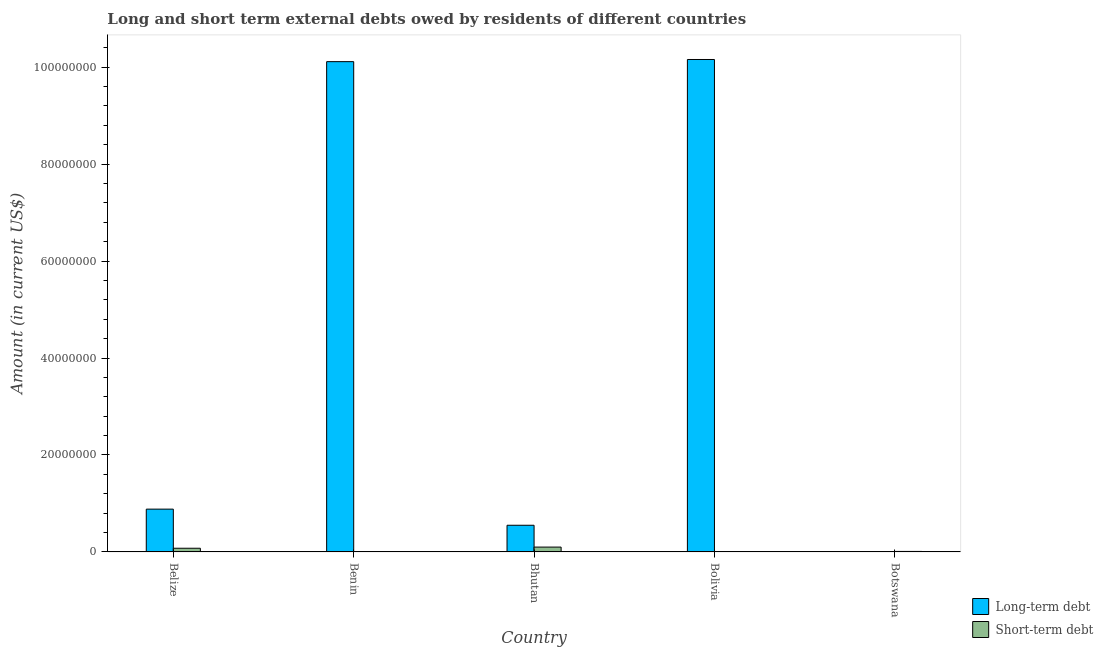What is the label of the 2nd group of bars from the left?
Your response must be concise. Benin. In how many cases, is the number of bars for a given country not equal to the number of legend labels?
Your answer should be very brief. 3. What is the short-term debts owed by residents in Belize?
Ensure brevity in your answer.  7.56e+05. Across all countries, what is the maximum long-term debts owed by residents?
Provide a short and direct response. 1.02e+08. What is the total short-term debts owed by residents in the graph?
Ensure brevity in your answer.  1.85e+06. What is the difference between the short-term debts owed by residents in Belize and that in Botswana?
Your response must be concise. 6.56e+05. What is the difference between the long-term debts owed by residents in Benin and the short-term debts owed by residents in Belize?
Make the answer very short. 1.00e+08. What is the average long-term debts owed by residents per country?
Your response must be concise. 4.34e+07. What is the difference between the long-term debts owed by residents and short-term debts owed by residents in Bhutan?
Your response must be concise. 4.50e+06. In how many countries, is the long-term debts owed by residents greater than 24000000 US$?
Offer a terse response. 2. What is the ratio of the long-term debts owed by residents in Benin to that in Bolivia?
Give a very brief answer. 1. What is the difference between the highest and the second highest long-term debts owed by residents?
Give a very brief answer. 4.45e+05. What is the difference between the highest and the lowest long-term debts owed by residents?
Your response must be concise. 1.02e+08. In how many countries, is the long-term debts owed by residents greater than the average long-term debts owed by residents taken over all countries?
Offer a terse response. 2. How many countries are there in the graph?
Give a very brief answer. 5. What is the difference between two consecutive major ticks on the Y-axis?
Your answer should be compact. 2.00e+07. Does the graph contain any zero values?
Offer a terse response. Yes. Does the graph contain grids?
Provide a succinct answer. No. Where does the legend appear in the graph?
Provide a succinct answer. Bottom right. How are the legend labels stacked?
Give a very brief answer. Vertical. What is the title of the graph?
Offer a very short reply. Long and short term external debts owed by residents of different countries. What is the Amount (in current US$) of Long-term debt in Belize?
Ensure brevity in your answer.  8.82e+06. What is the Amount (in current US$) in Short-term debt in Belize?
Keep it short and to the point. 7.56e+05. What is the Amount (in current US$) in Long-term debt in Benin?
Keep it short and to the point. 1.01e+08. What is the Amount (in current US$) in Short-term debt in Benin?
Offer a very short reply. 0. What is the Amount (in current US$) of Long-term debt in Bhutan?
Your response must be concise. 5.50e+06. What is the Amount (in current US$) of Short-term debt in Bhutan?
Keep it short and to the point. 9.94e+05. What is the Amount (in current US$) of Long-term debt in Bolivia?
Your response must be concise. 1.02e+08. What is the Amount (in current US$) of Short-term debt in Bolivia?
Your answer should be compact. 0. Across all countries, what is the maximum Amount (in current US$) in Long-term debt?
Your answer should be compact. 1.02e+08. Across all countries, what is the maximum Amount (in current US$) of Short-term debt?
Your answer should be very brief. 9.94e+05. What is the total Amount (in current US$) in Long-term debt in the graph?
Offer a terse response. 2.17e+08. What is the total Amount (in current US$) in Short-term debt in the graph?
Give a very brief answer. 1.85e+06. What is the difference between the Amount (in current US$) in Long-term debt in Belize and that in Benin?
Make the answer very short. -9.23e+07. What is the difference between the Amount (in current US$) in Long-term debt in Belize and that in Bhutan?
Your answer should be very brief. 3.33e+06. What is the difference between the Amount (in current US$) in Short-term debt in Belize and that in Bhutan?
Your answer should be compact. -2.38e+05. What is the difference between the Amount (in current US$) of Long-term debt in Belize and that in Bolivia?
Provide a succinct answer. -9.28e+07. What is the difference between the Amount (in current US$) of Short-term debt in Belize and that in Botswana?
Provide a succinct answer. 6.56e+05. What is the difference between the Amount (in current US$) of Long-term debt in Benin and that in Bhutan?
Your response must be concise. 9.56e+07. What is the difference between the Amount (in current US$) of Long-term debt in Benin and that in Bolivia?
Provide a short and direct response. -4.45e+05. What is the difference between the Amount (in current US$) of Long-term debt in Bhutan and that in Bolivia?
Ensure brevity in your answer.  -9.61e+07. What is the difference between the Amount (in current US$) of Short-term debt in Bhutan and that in Botswana?
Give a very brief answer. 8.94e+05. What is the difference between the Amount (in current US$) of Long-term debt in Belize and the Amount (in current US$) of Short-term debt in Bhutan?
Provide a short and direct response. 7.83e+06. What is the difference between the Amount (in current US$) in Long-term debt in Belize and the Amount (in current US$) in Short-term debt in Botswana?
Your answer should be very brief. 8.72e+06. What is the difference between the Amount (in current US$) in Long-term debt in Benin and the Amount (in current US$) in Short-term debt in Bhutan?
Your answer should be compact. 1.00e+08. What is the difference between the Amount (in current US$) of Long-term debt in Benin and the Amount (in current US$) of Short-term debt in Botswana?
Give a very brief answer. 1.01e+08. What is the difference between the Amount (in current US$) of Long-term debt in Bhutan and the Amount (in current US$) of Short-term debt in Botswana?
Ensure brevity in your answer.  5.40e+06. What is the difference between the Amount (in current US$) of Long-term debt in Bolivia and the Amount (in current US$) of Short-term debt in Botswana?
Your response must be concise. 1.01e+08. What is the average Amount (in current US$) of Long-term debt per country?
Your response must be concise. 4.34e+07. What is the difference between the Amount (in current US$) of Long-term debt and Amount (in current US$) of Short-term debt in Belize?
Offer a very short reply. 8.07e+06. What is the difference between the Amount (in current US$) of Long-term debt and Amount (in current US$) of Short-term debt in Bhutan?
Keep it short and to the point. 4.50e+06. What is the ratio of the Amount (in current US$) of Long-term debt in Belize to that in Benin?
Your response must be concise. 0.09. What is the ratio of the Amount (in current US$) in Long-term debt in Belize to that in Bhutan?
Give a very brief answer. 1.61. What is the ratio of the Amount (in current US$) in Short-term debt in Belize to that in Bhutan?
Your answer should be very brief. 0.76. What is the ratio of the Amount (in current US$) in Long-term debt in Belize to that in Bolivia?
Keep it short and to the point. 0.09. What is the ratio of the Amount (in current US$) of Short-term debt in Belize to that in Botswana?
Provide a short and direct response. 7.56. What is the ratio of the Amount (in current US$) of Long-term debt in Benin to that in Bhutan?
Provide a short and direct response. 18.4. What is the ratio of the Amount (in current US$) of Long-term debt in Benin to that in Bolivia?
Provide a succinct answer. 1. What is the ratio of the Amount (in current US$) of Long-term debt in Bhutan to that in Bolivia?
Offer a terse response. 0.05. What is the ratio of the Amount (in current US$) of Short-term debt in Bhutan to that in Botswana?
Offer a very short reply. 9.94. What is the difference between the highest and the second highest Amount (in current US$) of Long-term debt?
Make the answer very short. 4.45e+05. What is the difference between the highest and the second highest Amount (in current US$) of Short-term debt?
Provide a short and direct response. 2.38e+05. What is the difference between the highest and the lowest Amount (in current US$) of Long-term debt?
Offer a terse response. 1.02e+08. What is the difference between the highest and the lowest Amount (in current US$) in Short-term debt?
Your answer should be very brief. 9.94e+05. 